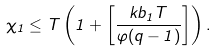<formula> <loc_0><loc_0><loc_500><loc_500>\chi _ { 1 } \leq T \left ( 1 + \left [ \frac { k b _ { 1 } T } { \varphi ( q - 1 ) } \right ] \right ) .</formula> 